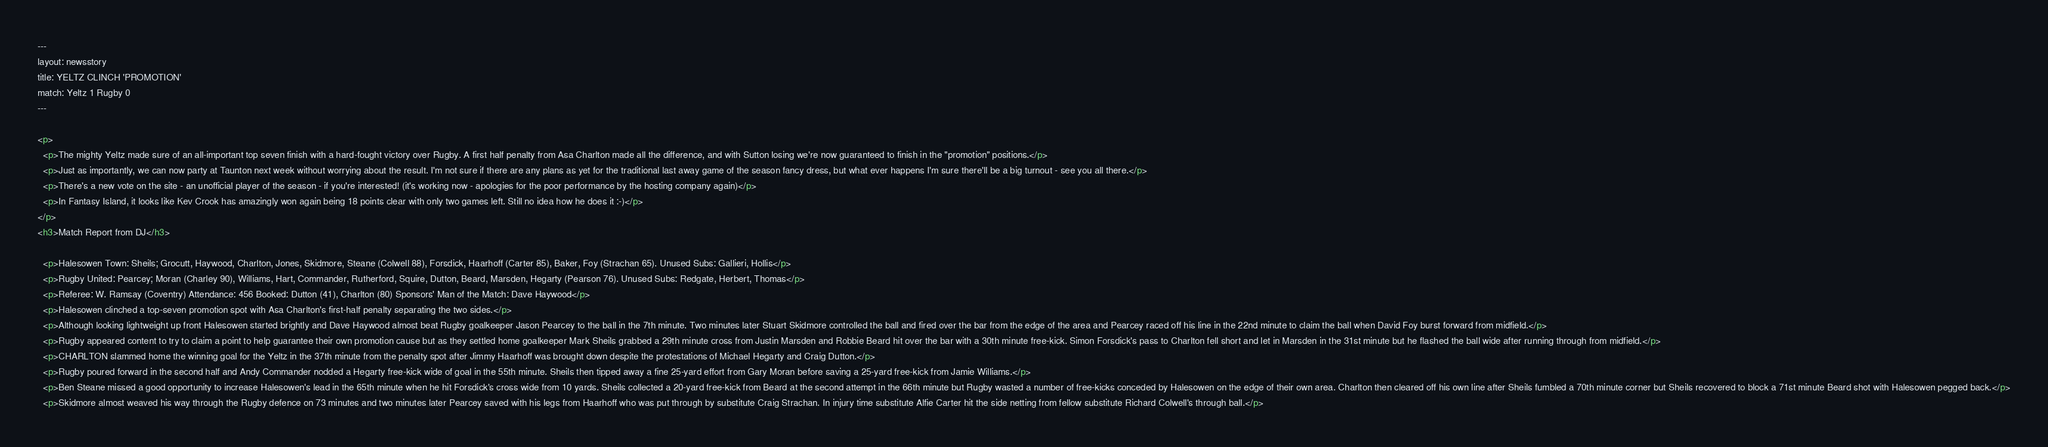Convert code to text. <code><loc_0><loc_0><loc_500><loc_500><_HTML_>---
layout: newsstory
title: YELTZ CLINCH 'PROMOTION'
match: Yeltz 1 Rugby 0
---

<p>
  <p>The mighty Yeltz made sure of an all-important top seven finish with a hard-fought victory over Rugby. A first half penalty from Asa Charlton made all the difference, and with Sutton losing we're now guaranteed to finish in the "promotion" positions.</p>
  <p>Just as importantly, we can now party at Taunton next week without worrying about the result. I'm not sure if there are any plans as yet for the traditional last away game of the season fancy dress, but what ever happens I'm sure there'll be a big turnout - see you all there.</p>
  <p>There's a new vote on the site - an unofficial player of the season - if you're interested! (it's working now - apologies for the poor performance by the hosting company again)</p>
  <p>In Fantasy Island, it looks like Kev Crook has amazingly won again being 18 points clear with only two games left. Still no idea how he does it :-)</p>
</p>
<h3>Match Report from DJ</h3>

  <p>Halesowen Town: Sheils; Grocutt, Haywood, Charlton, Jones, Skidmore, Steane (Colwell 88), Forsdick, Haarhoff (Carter 85), Baker, Foy (Strachan 65). Unused Subs: Gallieri, Hollis</p>
  <p>Rugby United: Pearcey; Moran (Charley 90), Williams, Hart, Commander, Rutherford, Squire, Dutton, Beard, Marsden, Hegarty (Pearson 76). Unused Subs: Redgate, Herbert, Thomas</p>
  <p>Referee: W. Ramsay (Coventry) Attendance: 456 Booked: Dutton (41), Charlton (80) Sponsors' Man of the Match: Dave Haywood</p>
  <p>Halesowen clinched a top-seven promotion spot with Asa Charlton's first-half penalty separating the two sides.</p>
  <p>Although looking lightweight up front Halesowen started brightly and Dave Haywood almost beat Rugby goalkeeper Jason Pearcey to the ball in the 7th minute. Two minutes later Stuart Skidmore controlled the ball and fired over the bar from the edge of the area and Pearcey raced off his line in the 22nd minute to claim the ball when David Foy burst forward from midfield.</p>
  <p>Rugby appeared content to try to claim a point to help guarantee their own promotion cause but as they settled home goalkeeper Mark Sheils grabbed a 29th minute cross from Justin Marsden and Robbie Beard hit over the bar with a 30th minute free-kick. Simon Forsdick's pass to Charlton fell short and let in Marsden in the 31st minute but he flashed the ball wide after running through from midfield.</p>
  <p>CHARLTON slammed home the winning goal for the Yeltz in the 37th minute from the penalty spot after Jimmy Haarhoff was brought down despite the protestations of Michael Hegarty and Craig Dutton.</p>
  <p>Rugby poured forward in the second half and Andy Commander nodded a Hegarty free-kick wide of goal in the 55th minute. Sheils then tipped away a fine 25-yard effort from Gary Moran before saving a 25-yard free-kick from Jamie Williams.</p>
  <p>Ben Steane missed a good opportunity to increase Halesowen's lead in the 65th minute when he hit Forsdick's cross wide from 10 yards. Sheils collected a 20-yard free-kick from Beard at the second attempt in the 66th minute but Rugby wasted a number of free-kicks conceded by Halesowen on the edge of their own area. Charlton then cleared off his own line after Sheils fumbled a 70th minute corner but Sheils recovered to block a 71st minute Beard shot with Halesowen pegged back.</p>
  <p>Skidmore almost weaved his way through the Rugby defence on 73 minutes and two minutes later Pearcey saved with his legs from Haarhoff who was put through by substitute Craig Strachan. In injury time substitute Alfie Carter hit the side netting from fellow substitute Richard Colwell's through ball.</p>

</code> 